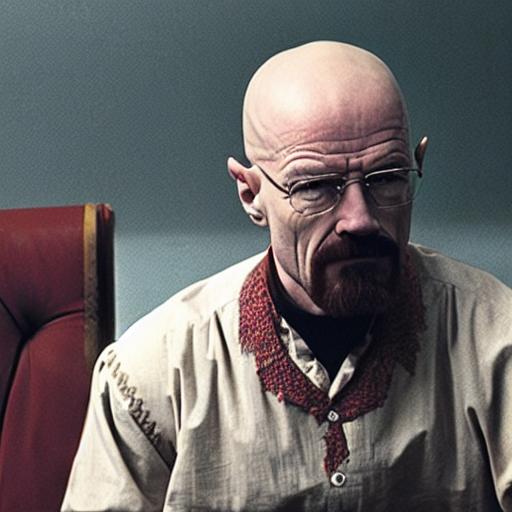What kind of mood does the overall image evoke? The image evokes a mood of tension and contemplation. The character's focused gaze and the sober background work together to create a feeling of intense introspection or silent plotting. 